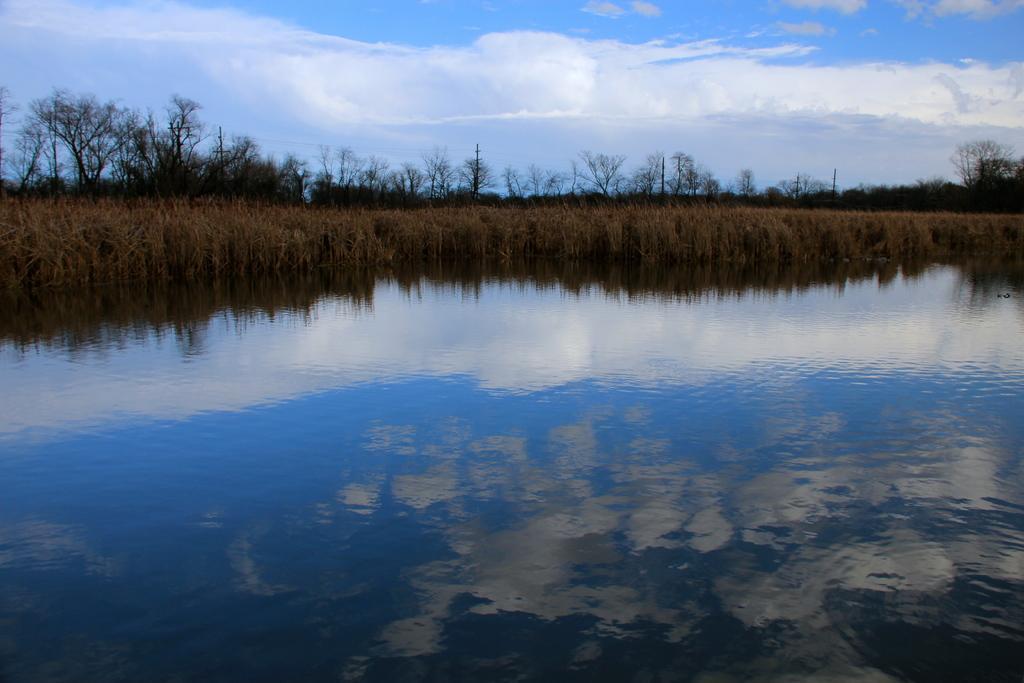Describe this image in one or two sentences. At the bottom of the image there is water. Behind the water there is grass and also there are trees. At the top of the image there is a sky with clouds. 